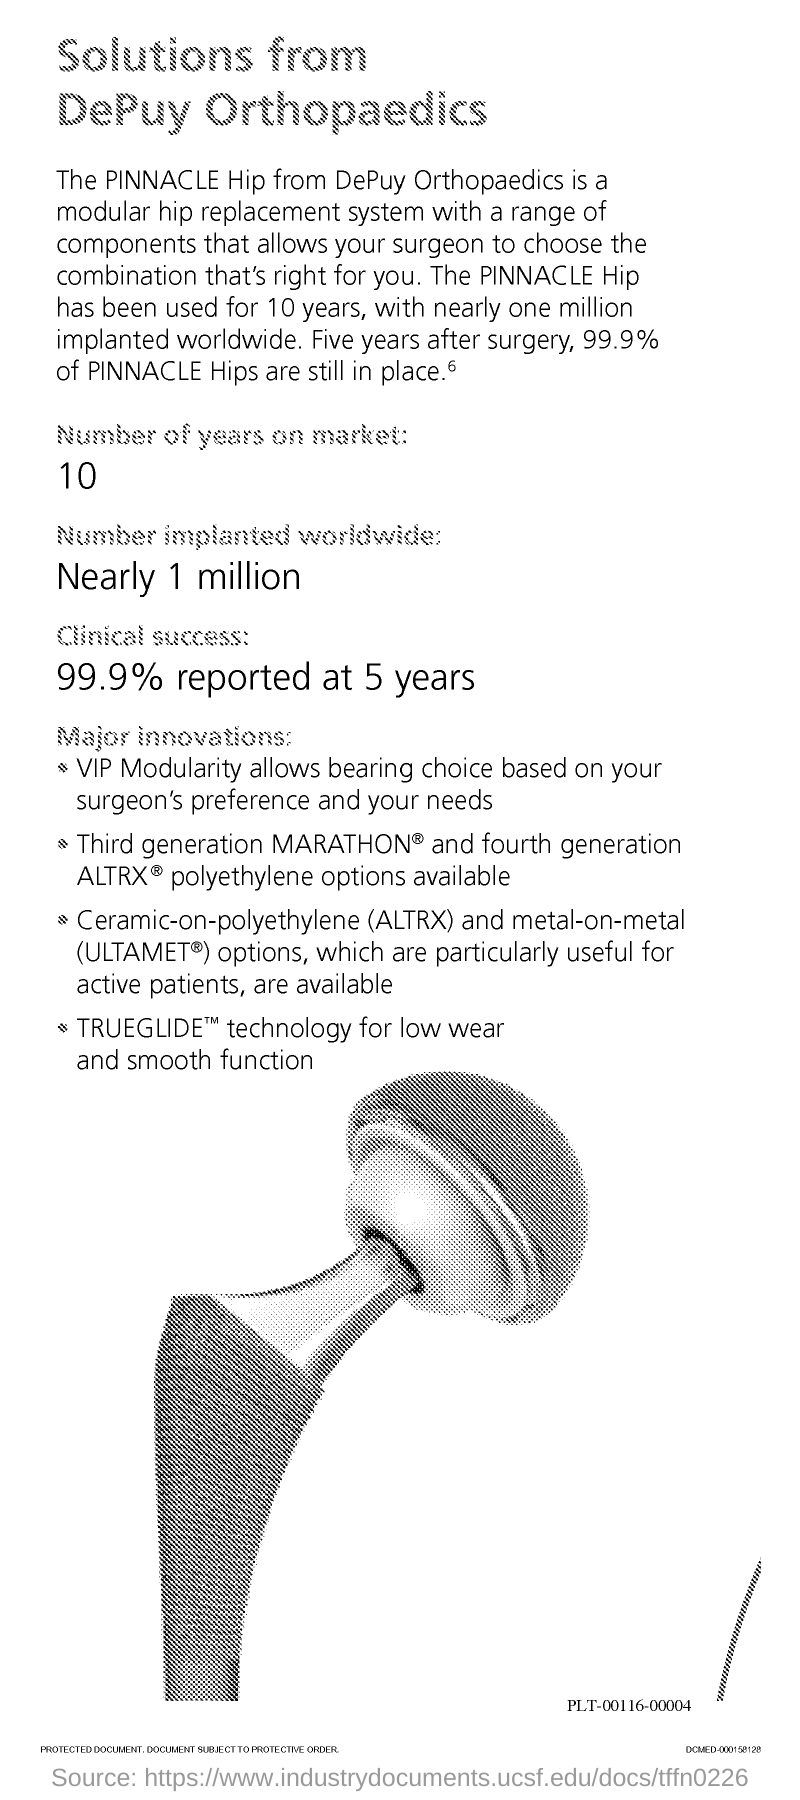Draw attention to some important aspects in this diagram. Nearly 1 million PINNACLE Hip implants have been implanted worldwide. The reported clinical success rate of the PINNACLE Hip is 99.9% at 5 years. The PINNACLE Hip has been on the market for 10 years. 